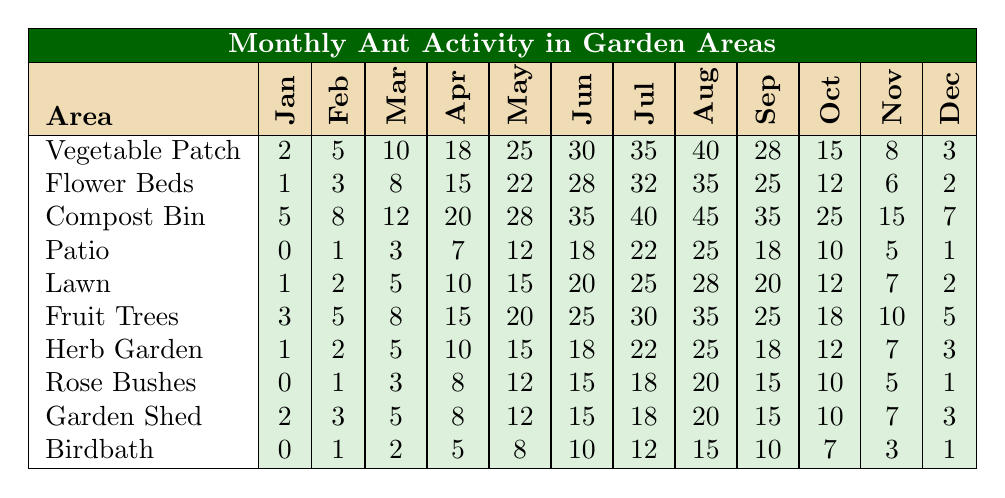What was the highest number of ants recorded in the compost bin? Looking at the row for the compost bin, the values for each month show a peak of 45 ants in August, which is the highest recorded value in that row.
Answer: 45 Which garden area had the lowest ant activity in January? Checking the table for January, the patio and the rose bushes both have 0 ants, which is the lowest recorded value among all areas.
Answer: Patio and Rose Bushes What is the total number of ants reported in the vegetable patch over the year? By adding the monthly values for the vegetable patch: 2 + 5 + 10 + 18 + 25 + 30 + 35 + 40 + 28 + 15 + 8 + 3 =  0. Therefore, the total is 88.
Answer: 88 Which area showed consistent growth in ant activity from January to August? Analyzing the values, the compost bin starts at 5 in January and increases to 45 in August, showing consistent growth month by month.
Answer: Compost Bin Is there any month where the lawn had more ant activity than the flower beds? Comparing the monthly values, the lawn shows higher activity in the months of May, June, July, and August. Therefore, there are indeed months where the lawn exceeds the flower beds.
Answer: Yes What is the percentage increase in ant activity in the fruit trees from January to July? The value for the fruit trees in January is 3 and in July it is 30. To calculate the percentage increase: ((30 - 3) / 3) * 100 = 900%.
Answer: 900% Which area had a total ant activity of 15 in October? A quick scan of the values for October reveals that both the compost bin and the herb garden show a total of 15 ants each.
Answer: Compost Bin and Herb Garden What is the average number of ants in the patio area across the year? The monthly values for the patio are 0, 1, 3, 7, 12, 18, 22, 25, 18, 10, 5, and 1. Adding these gives a total of 112, which when divided by 12 months gives an average of approximately 9.33.
Answer: Approximately 9.33 Does the birdbath consistently have higher activity than the rose bushes? Comparing the values month by month, the birdbath has higher or equal activity than the rose bushes during most months, particularly in May, June, July, September, and October.
Answer: Yes Which month had the greatest decrease in ant activity in the lawn area compared to the previous month? By comparing the monthly values for the lawn, the greatest drop occurs from July (25) to August (20), a decrease of 5 ants.
Answer: 5 (from July to August) 